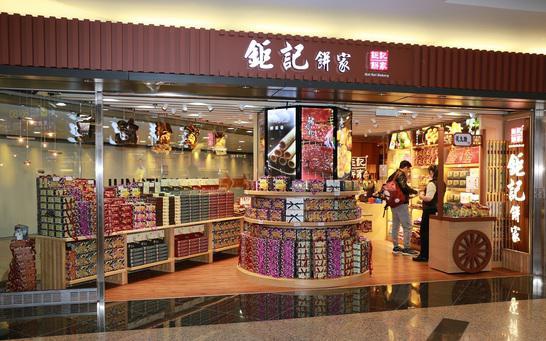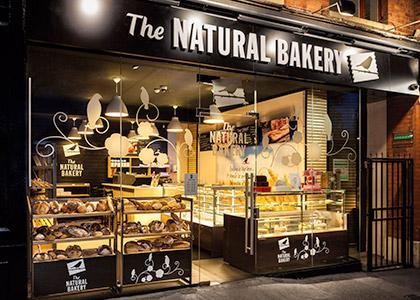The first image is the image on the left, the second image is the image on the right. Given the left and right images, does the statement "At least one female with back to the camera is at a service counter in one image." hold true? Answer yes or no. No. 